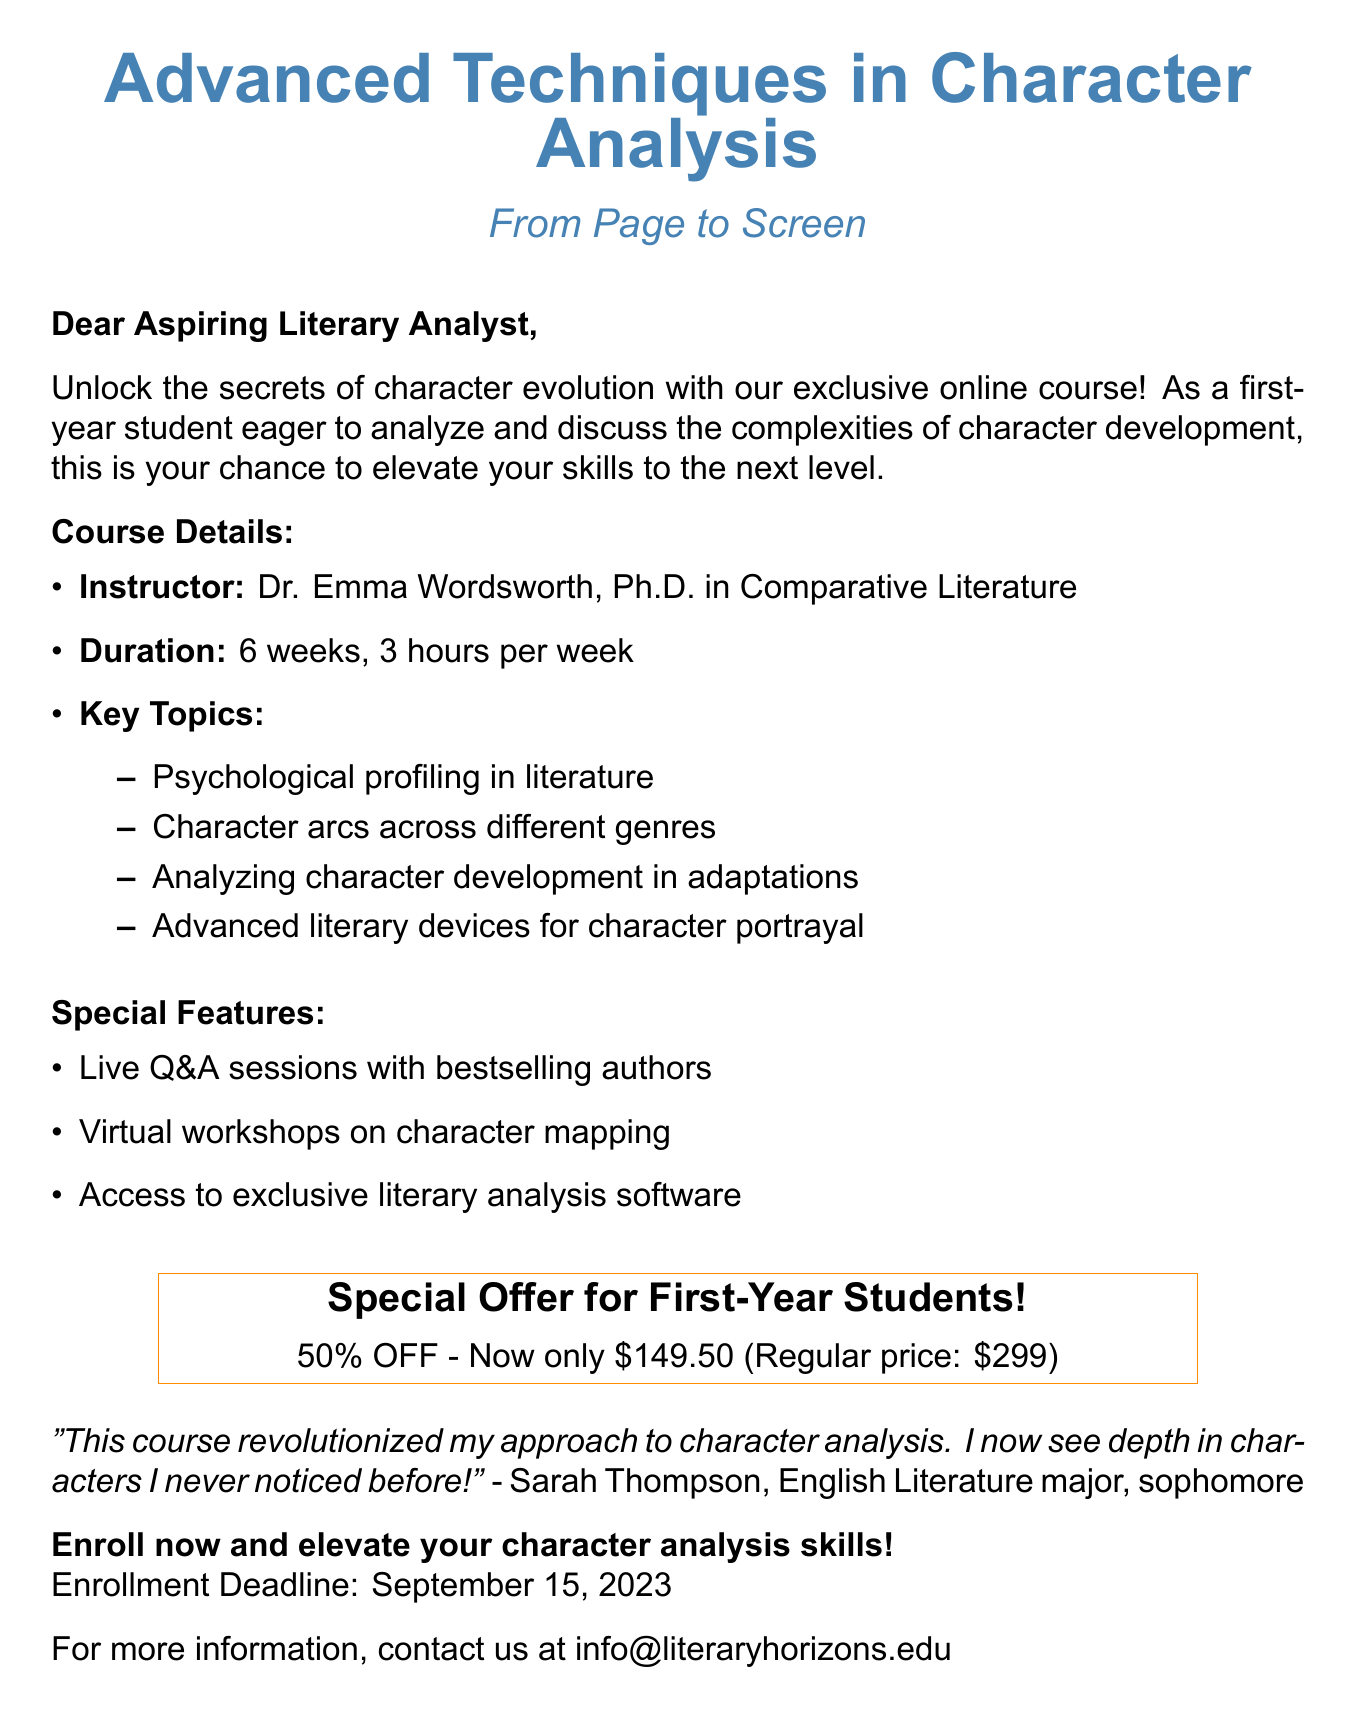What is the course title? The course title is specified in the document as the main focus of the email, highlighting its topic.
Answer: Advanced Techniques in Character Analysis: From Page to Screen Who is the instructor? The instructor is identified in the course details section, providing credibility and expertise for the course.
Answer: Dr. Emma Wordsworth, Ph.D. in Comparative Literature What is the duration of the course? The duration indicates how long the course will last and is a key detail for potential students regarding their commitment.
Answer: 6 weeks, 3 hours per week What is the special discount for first-year students? The document explicitly states the discount available for first-year students as part of the promotional offer.
Answer: 50% off for first-year students What was the original price of the course? The original price is outlined in the special offer section, giving potential students a comparison for the discounted rate.
Answer: $299 What is the enrollment deadline? The deadline is crucial for students to know when they must sign up for the course.
Answer: September 15, 2023 Which literary aspect does the course focus on? This question requires understanding the main theme of the course and its relevance to character analysis.
Answer: Character analysis What feedback does the testimonial provide? The testimonial offers personal insight into the effectiveness of the course, which can influence potential students’ decisions.
Answer: This course revolutionized my approach to character analysis 